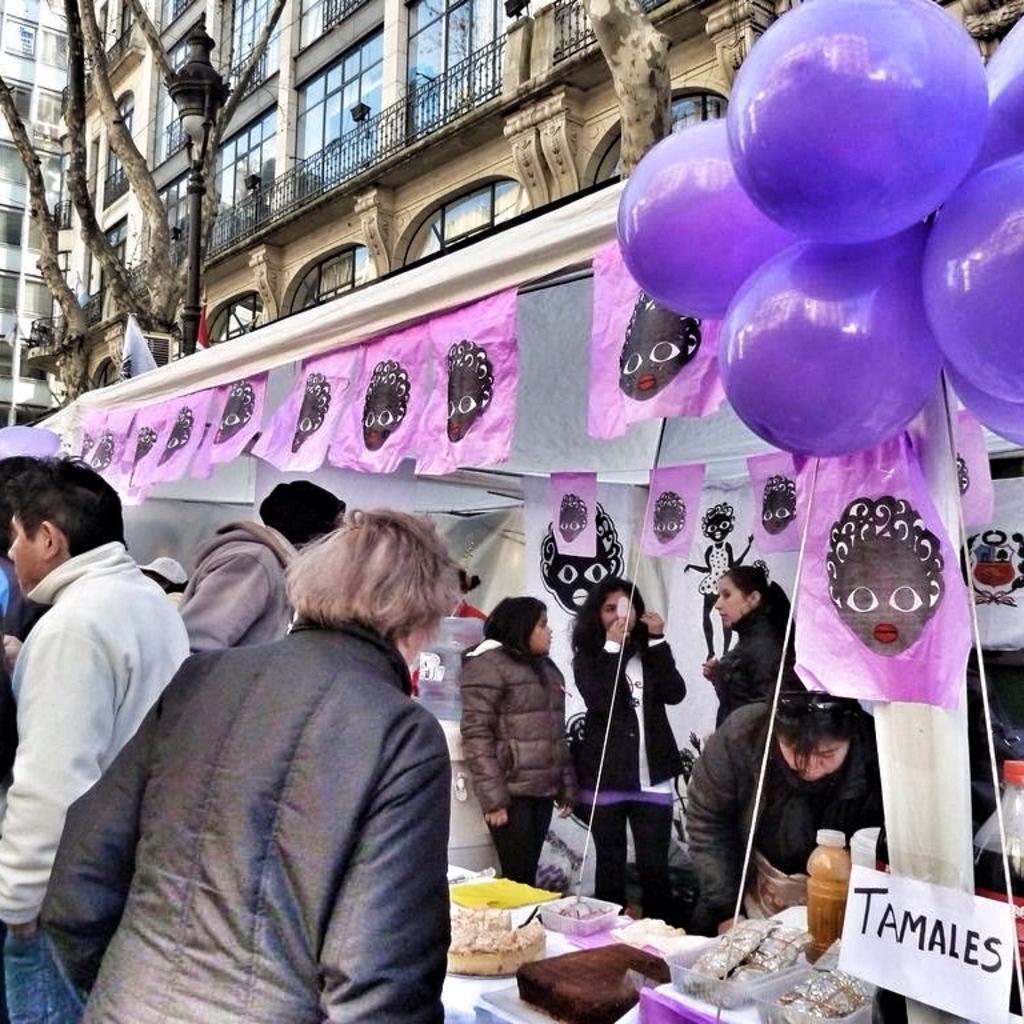Please provide a concise description of this image. In this image I see a stall and there are lots of people in it and everyone are wearing jackets and in the stall there is food and on the top of the stall there are balloons which are of purple in color and we can also see a paper, which says Tamales. In the background we can see a large building and few trees and there is also a street light. 